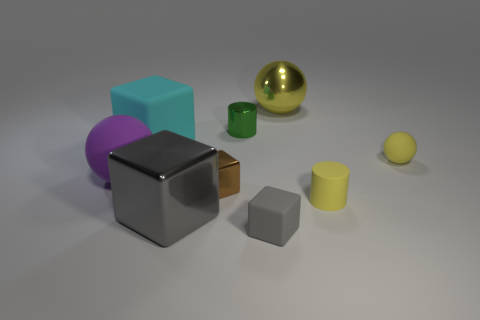Subtract all big cyan matte blocks. How many blocks are left? 3 Subtract 3 blocks. How many blocks are left? 1 Add 1 gray shiny things. How many objects exist? 10 Subtract all cyan blocks. How many blocks are left? 3 Subtract all blocks. How many objects are left? 5 Subtract all red cylinders. How many red cubes are left? 0 Subtract all yellow shiny cylinders. Subtract all small yellow rubber cylinders. How many objects are left? 8 Add 9 small green things. How many small green things are left? 10 Add 9 tiny yellow cylinders. How many tiny yellow cylinders exist? 10 Subtract 0 green cubes. How many objects are left? 9 